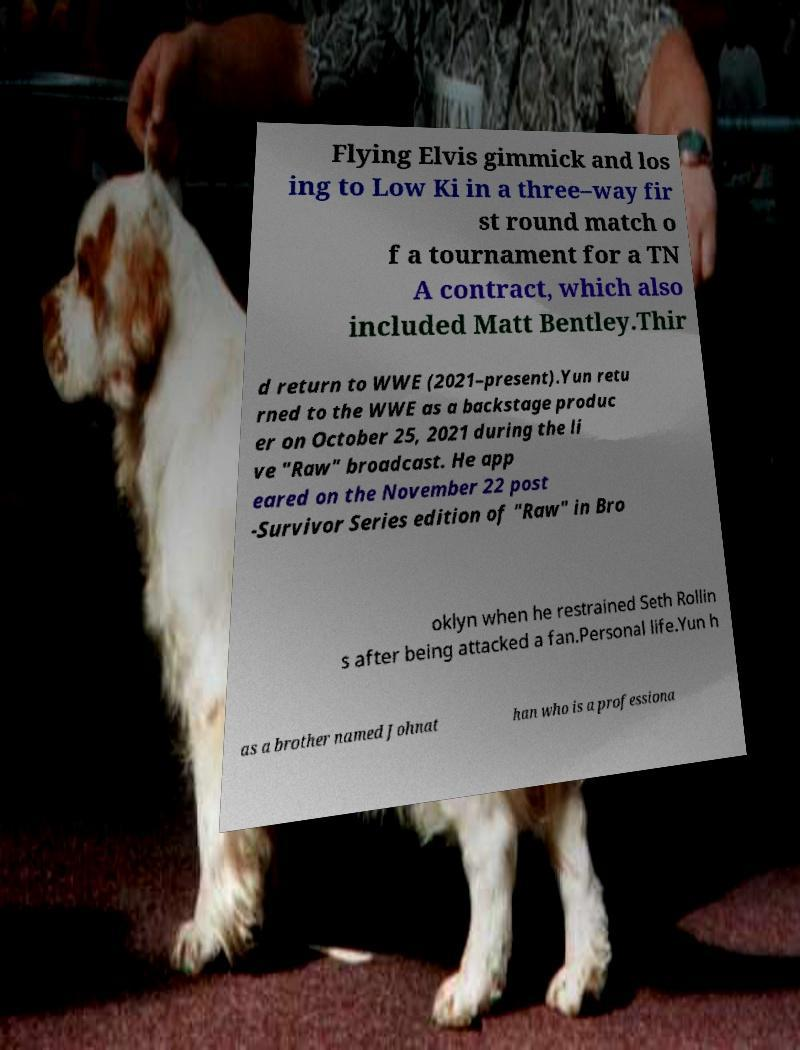Can you accurately transcribe the text from the provided image for me? Flying Elvis gimmick and los ing to Low Ki in a three–way fir st round match o f a tournament for a TN A contract, which also included Matt Bentley.Thir d return to WWE (2021–present).Yun retu rned to the WWE as a backstage produc er on October 25, 2021 during the li ve "Raw" broadcast. He app eared on the November 22 post -Survivor Series edition of "Raw" in Bro oklyn when he restrained Seth Rollin s after being attacked a fan.Personal life.Yun h as a brother named Johnat han who is a professiona 